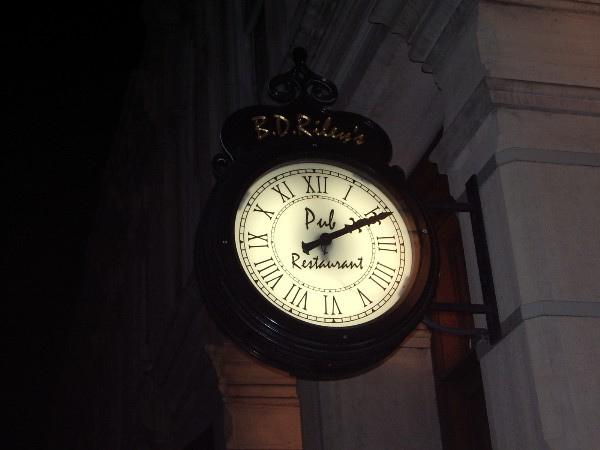What style of numbers are on the clock face?
Short answer required. Roman numerals. What color is the background?
Answer briefly. White. What two words are on the clock?
Give a very brief answer. Pub restaurant. What time does the clock say?
Give a very brief answer. 2:10. What time is it?
Answer briefly. 2:11. Is it daytime?
Quick response, please. No. 